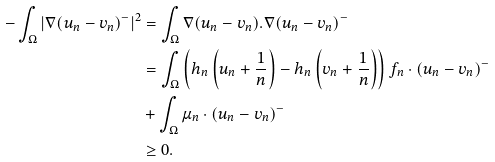Convert formula to latex. <formula><loc_0><loc_0><loc_500><loc_500>- \int _ { \Omega } | \nabla ( u _ { n } - v _ { n } ) ^ { - } | ^ { 2 } & = \int _ { \Omega } \nabla ( u _ { n } - v _ { n } ) . \nabla ( u _ { n } - v _ { n } ) ^ { - } \\ & = \int _ { \Omega } \left ( h _ { n } \left ( u _ { n } + \frac { 1 } { n } \right ) - h _ { n } \left ( v _ { n } + \frac { 1 } { n } \right ) \right ) f _ { n } \cdot ( u _ { n } - v _ { n } ) ^ { - } \\ & + \int _ { \Omega } \mu _ { n } \cdot ( u _ { n } - v _ { n } ) ^ { - } \\ & \geq 0 .</formula> 